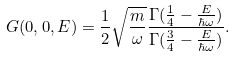Convert formula to latex. <formula><loc_0><loc_0><loc_500><loc_500>G ( 0 , 0 , E ) = \frac { 1 } { 2 } \sqrt { \frac { m } { \omega } } \frac { \Gamma ( \frac { 1 } { 4 } - \frac { E } { \hbar { \omega } } ) } { \Gamma ( \frac { 3 } { 4 } - \frac { E } { \hbar { \omega } } ) } .</formula> 